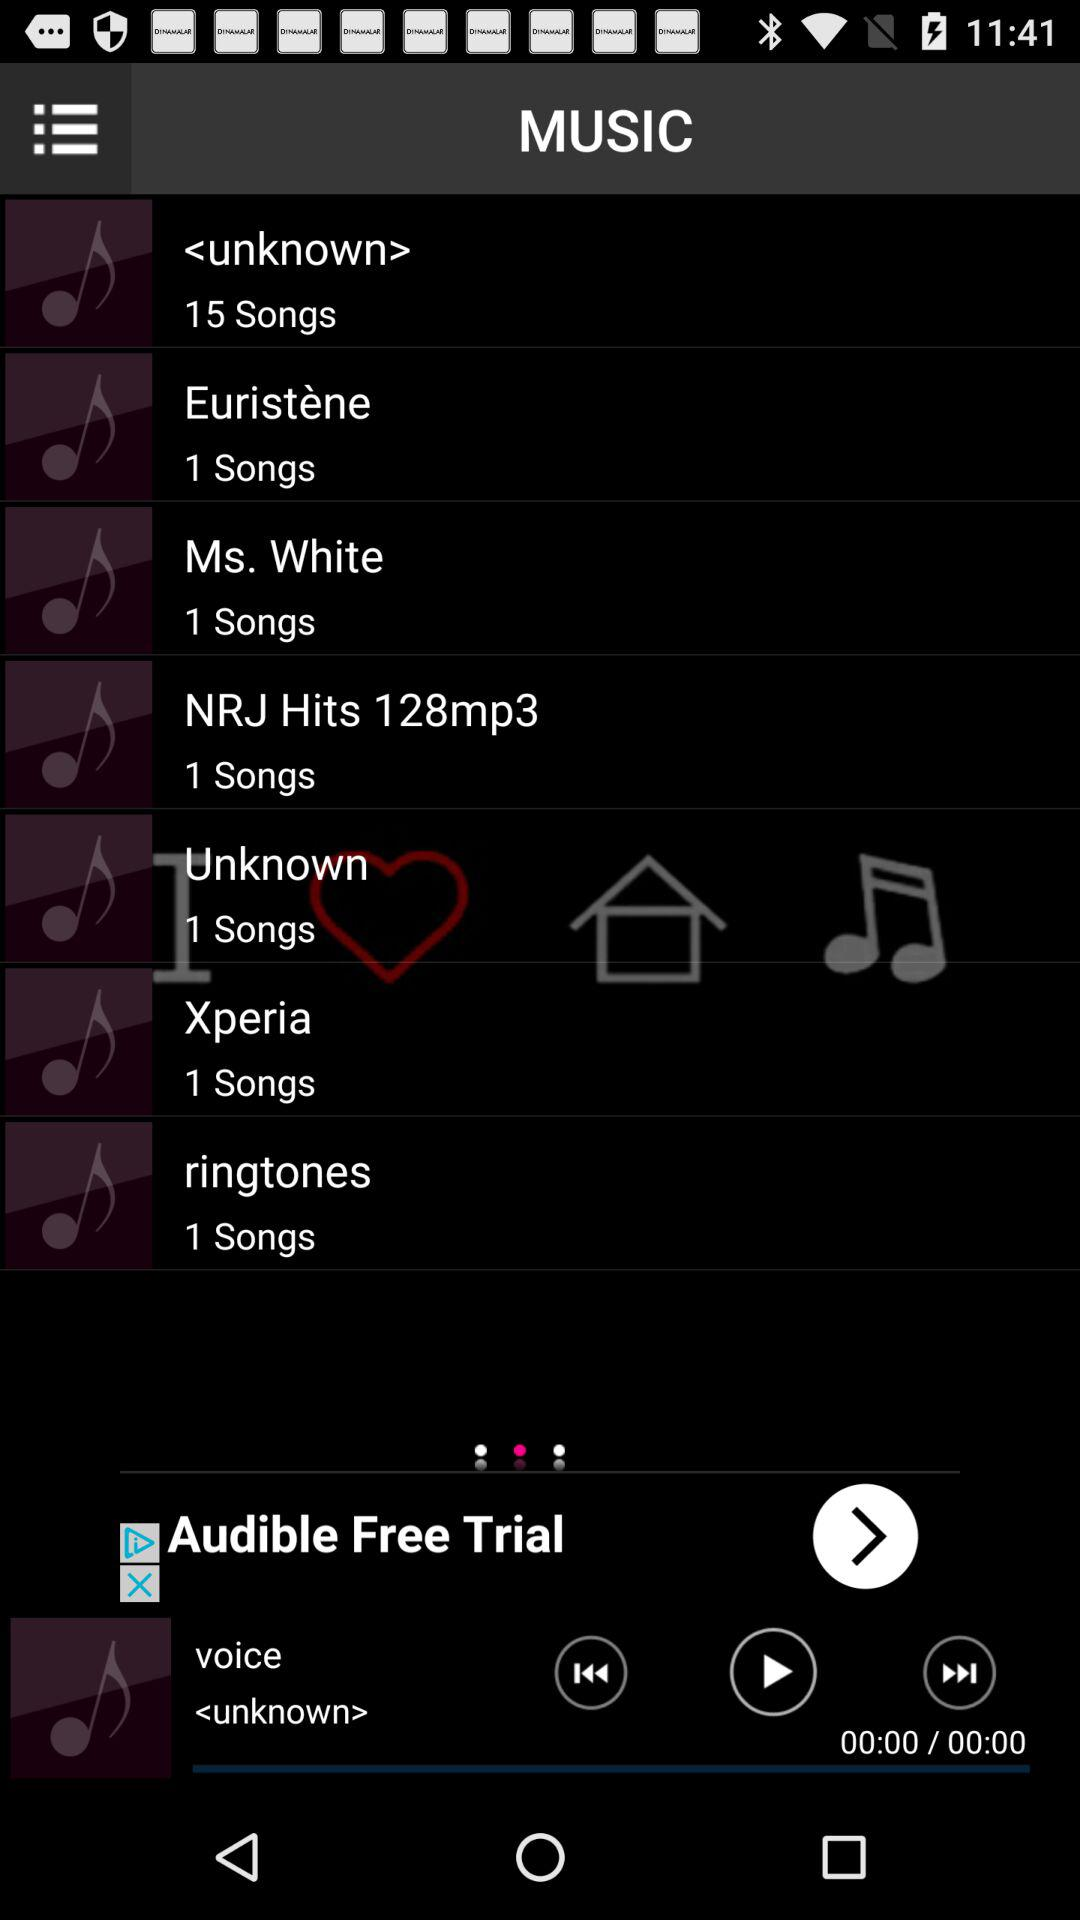How many songs are there in the "NRJ Hits 128mp3" album? There is 1 song in the "NRJ Hits 128mp3" album. 